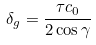Convert formula to latex. <formula><loc_0><loc_0><loc_500><loc_500>\delta _ { g } = \frac { \tau c _ { 0 } } { 2 \cos \gamma }</formula> 